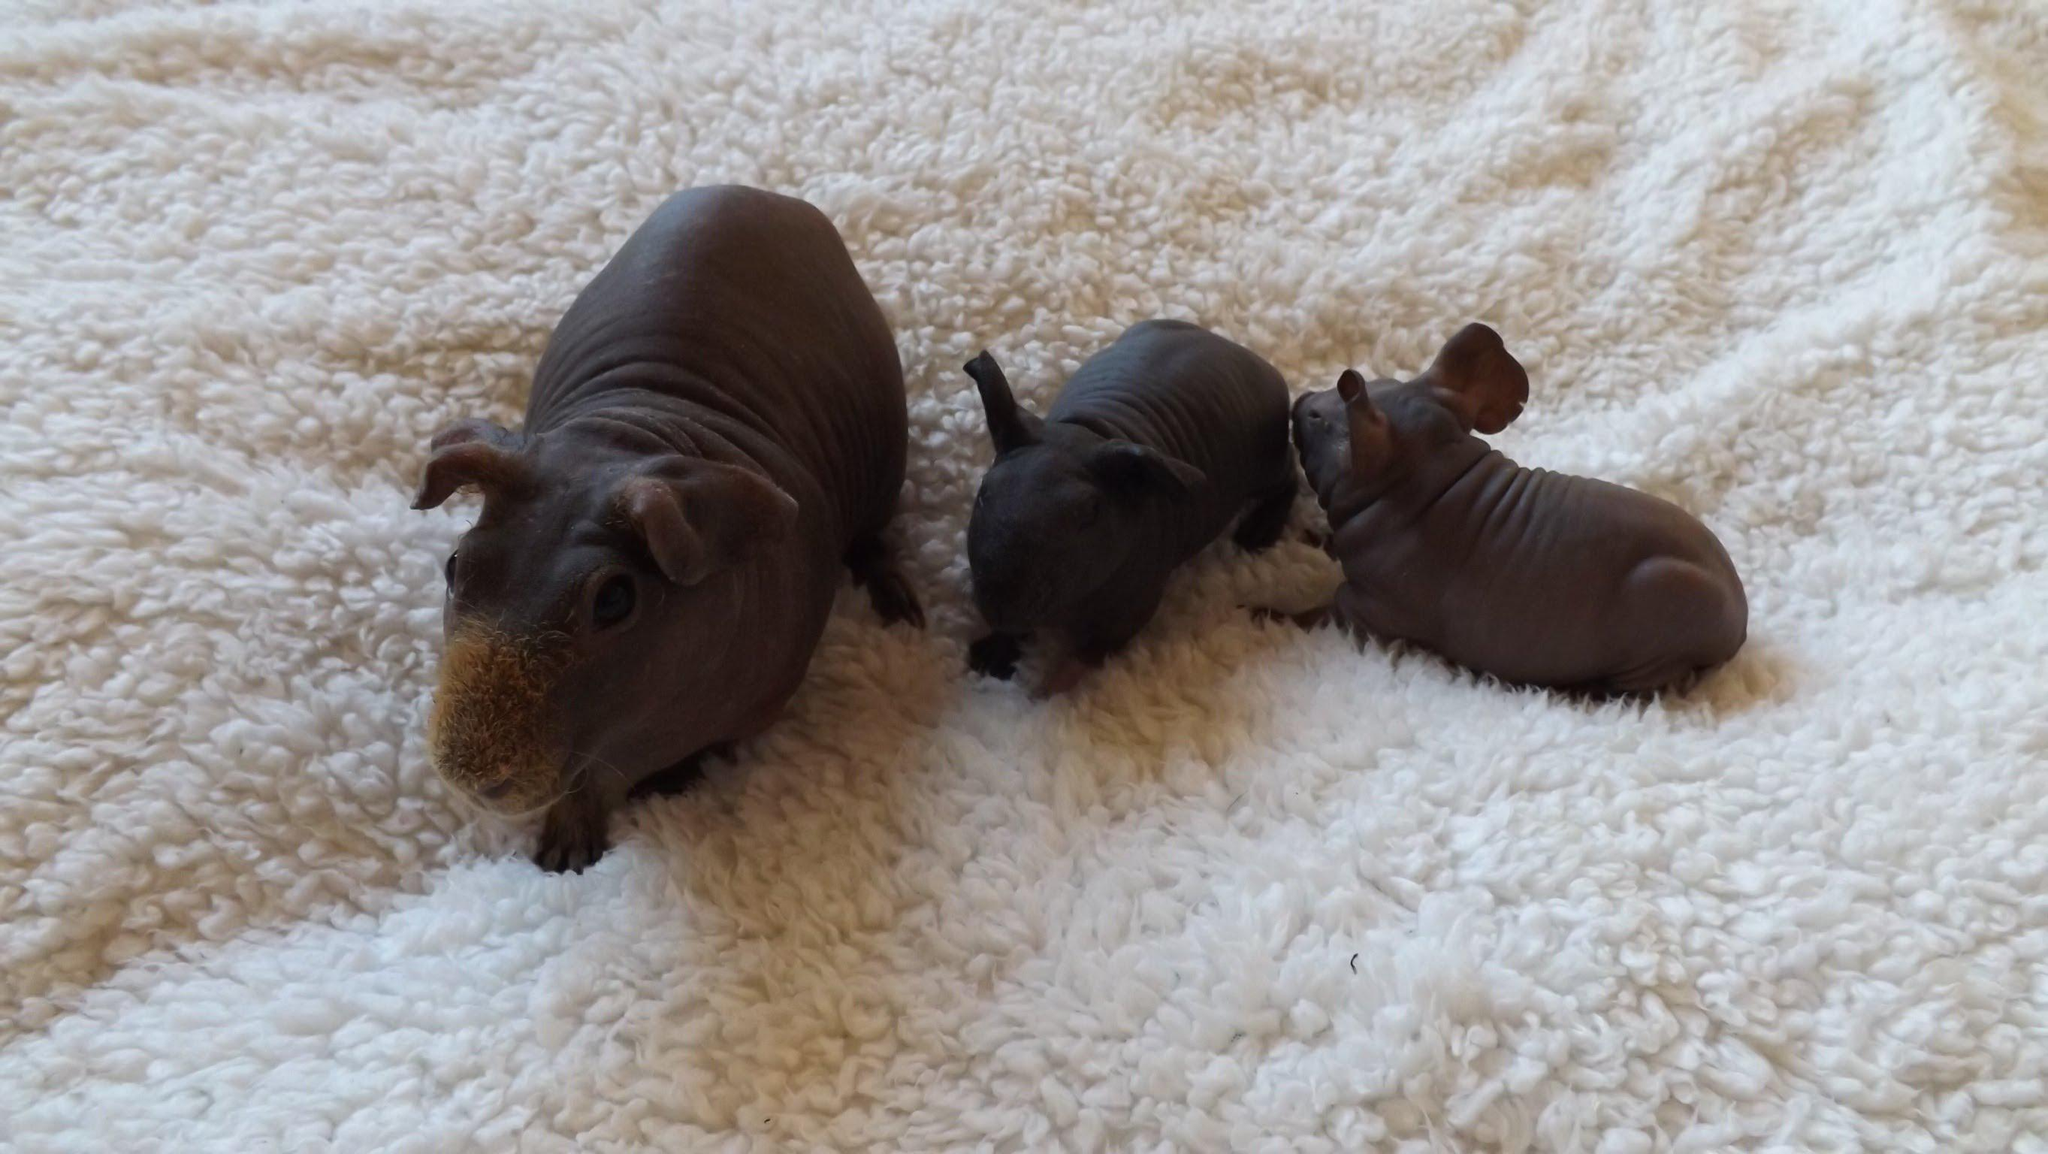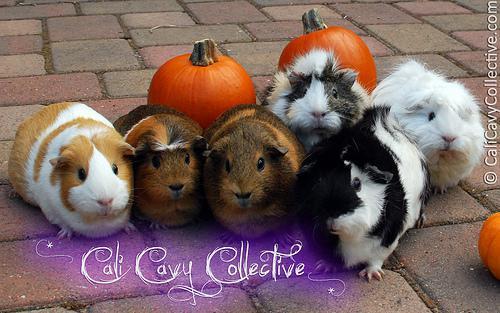The first image is the image on the left, the second image is the image on the right. For the images shown, is this caption "Neither individual image includes more than seven guinea pigs." true? Answer yes or no. Yes. The first image is the image on the left, the second image is the image on the right. Analyze the images presented: Is the assertion "Several guinea pigs are eating hay." valid? Answer yes or no. No. 